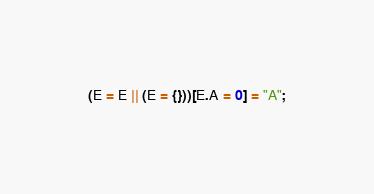Convert code to text. <code><loc_0><loc_0><loc_500><loc_500><_JavaScript_>(E = E || (E = {}))[E.A = 0] = "A";
</code> 